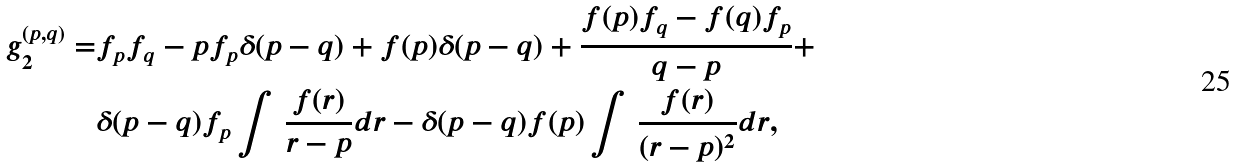<formula> <loc_0><loc_0><loc_500><loc_500>g _ { 2 } ^ { ( p , q ) } = & f _ { p } f _ { q } - p f _ { p } \delta ( p - q ) + f ( p ) \delta ( p - q ) + \frac { f ( p ) f _ { q } - f ( q ) f _ { p } } { q - p } + \\ & \delta ( p - q ) f _ { p } \int \, \frac { f ( r ) } { r - p } d r - \delta ( p - q ) f ( p ) \int \, \frac { f ( r ) } { ( r - p ) ^ { 2 } } d r ,</formula> 